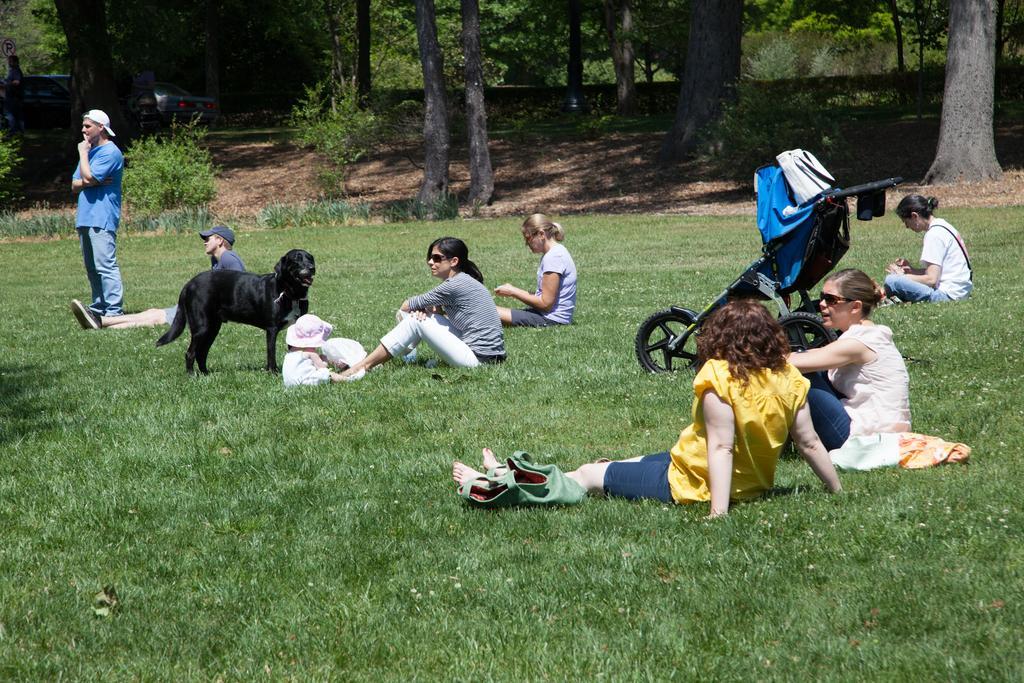In one or two sentences, can you explain what this image depicts? This image is clicked outside. There is grass in the middle. There are so many persons sitting on grass. There is a stroller on the right side. There is a dog on the left side. There are trees at the top. 